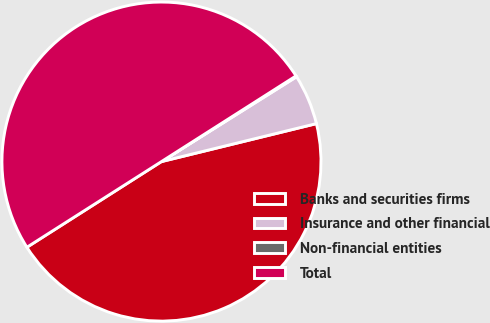Convert chart to OTSL. <chart><loc_0><loc_0><loc_500><loc_500><pie_chart><fcel>Banks and securities firms<fcel>Insurance and other financial<fcel>Non-financial entities<fcel>Total<nl><fcel>44.8%<fcel>5.1%<fcel>0.1%<fcel>50.0%<nl></chart> 